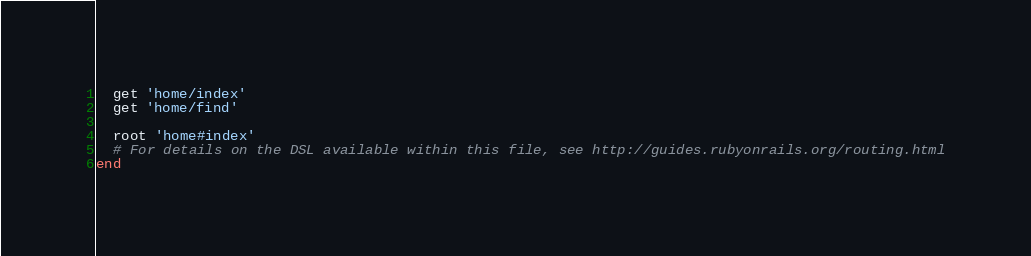<code> <loc_0><loc_0><loc_500><loc_500><_Ruby_>  get 'home/index'
  get 'home/find'

  root 'home#index'
  # For details on the DSL available within this file, see http://guides.rubyonrails.org/routing.html
end
</code> 